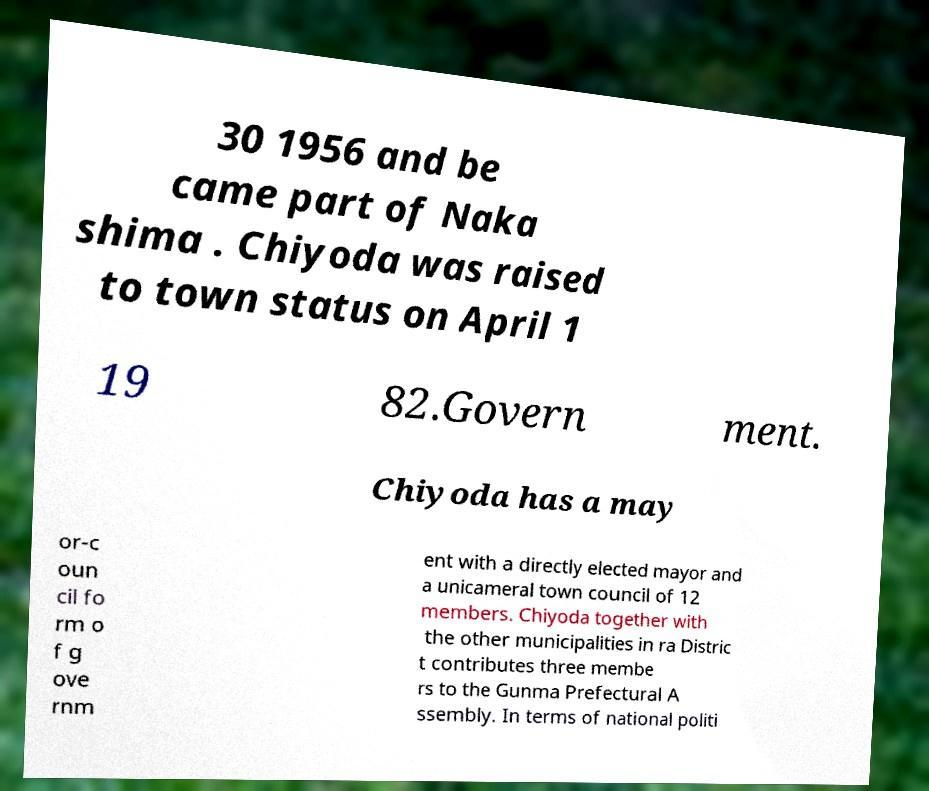Can you accurately transcribe the text from the provided image for me? 30 1956 and be came part of Naka shima . Chiyoda was raised to town status on April 1 19 82.Govern ment. Chiyoda has a may or-c oun cil fo rm o f g ove rnm ent with a directly elected mayor and a unicameral town council of 12 members. Chiyoda together with the other municipalities in ra Distric t contributes three membe rs to the Gunma Prefectural A ssembly. In terms of national politi 